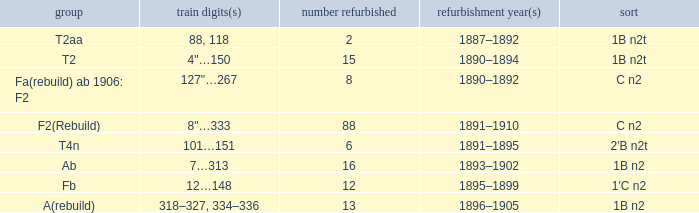I'm looking to parse the entire table for insights. Could you assist me with that? {'header': ['group', 'train digits(s)', 'number refurbished', 'refurbishment year(s)', 'sort'], 'rows': [['T2aa', '88, 118', '2', '1887–1892', '1B n2t'], ['T2', '4"…150', '15', '1890–1894', '1B n2t'], ['Fa(rebuild) ab 1906: F2', '127"…267', '8', '1890–1892', 'C n2'], ['F2(Rebuild)', '8"…333', '88', '1891–1910', 'C n2'], ['T4n', '101…151', '6', '1891–1895', '2′B n2t'], ['Ab', '7…313', '16', '1893–1902', '1B n2'], ['Fb', '12…148', '12', '1895–1899', '1′C n2'], ['A(rebuild)', '318–327, 334–336', '13', '1896–1905', '1B n2']]} What is the total of quantity rebuilt if the type is 1B N2T and the railway number is 88, 118? 1.0. 